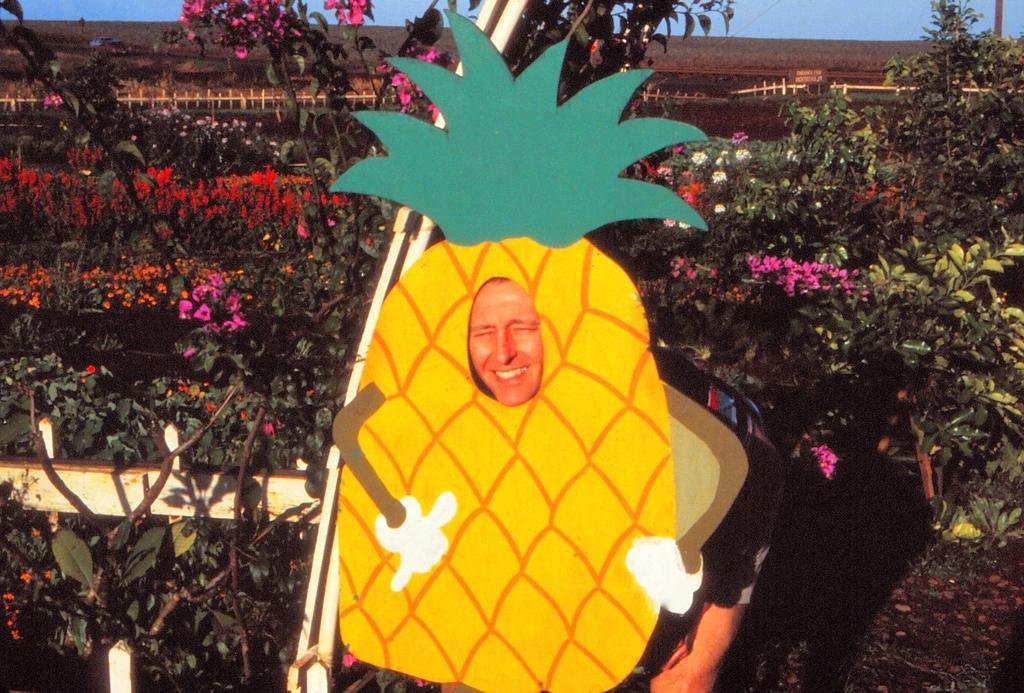Describe this image in one or two sentences. The picture is taken outside a city. In the foreground of the picture there is a person standing, in front of a apple costume. Behind him there are plants, flowers and railing. In the background there is field. Sky is clear and it is sunny. 